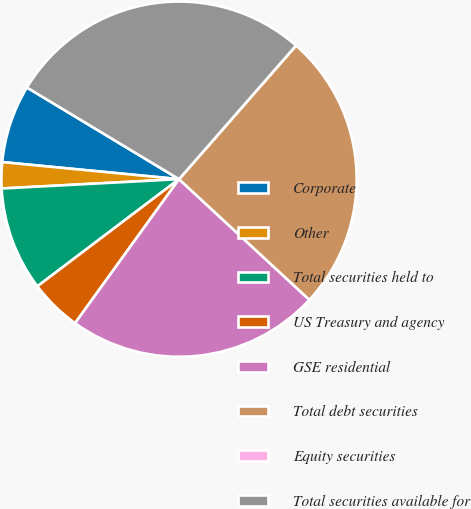Convert chart to OTSL. <chart><loc_0><loc_0><loc_500><loc_500><pie_chart><fcel>Corporate<fcel>Other<fcel>Total securities held to<fcel>US Treasury and agency<fcel>GSE residential<fcel>Total debt securities<fcel>Equity securities<fcel>Total securities available for<nl><fcel>7.1%<fcel>2.37%<fcel>9.47%<fcel>4.74%<fcel>23.07%<fcel>25.44%<fcel>0.0%<fcel>27.81%<nl></chart> 